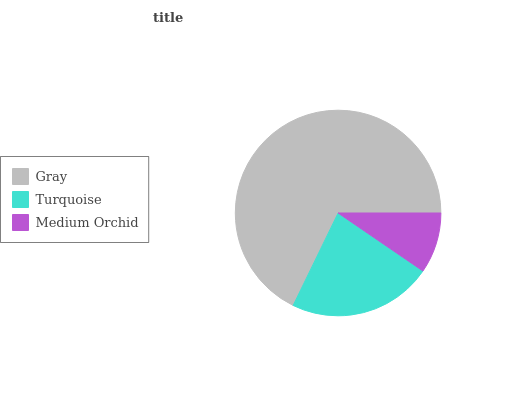Is Medium Orchid the minimum?
Answer yes or no. Yes. Is Gray the maximum?
Answer yes or no. Yes. Is Turquoise the minimum?
Answer yes or no. No. Is Turquoise the maximum?
Answer yes or no. No. Is Gray greater than Turquoise?
Answer yes or no. Yes. Is Turquoise less than Gray?
Answer yes or no. Yes. Is Turquoise greater than Gray?
Answer yes or no. No. Is Gray less than Turquoise?
Answer yes or no. No. Is Turquoise the high median?
Answer yes or no. Yes. Is Turquoise the low median?
Answer yes or no. Yes. Is Gray the high median?
Answer yes or no. No. Is Gray the low median?
Answer yes or no. No. 